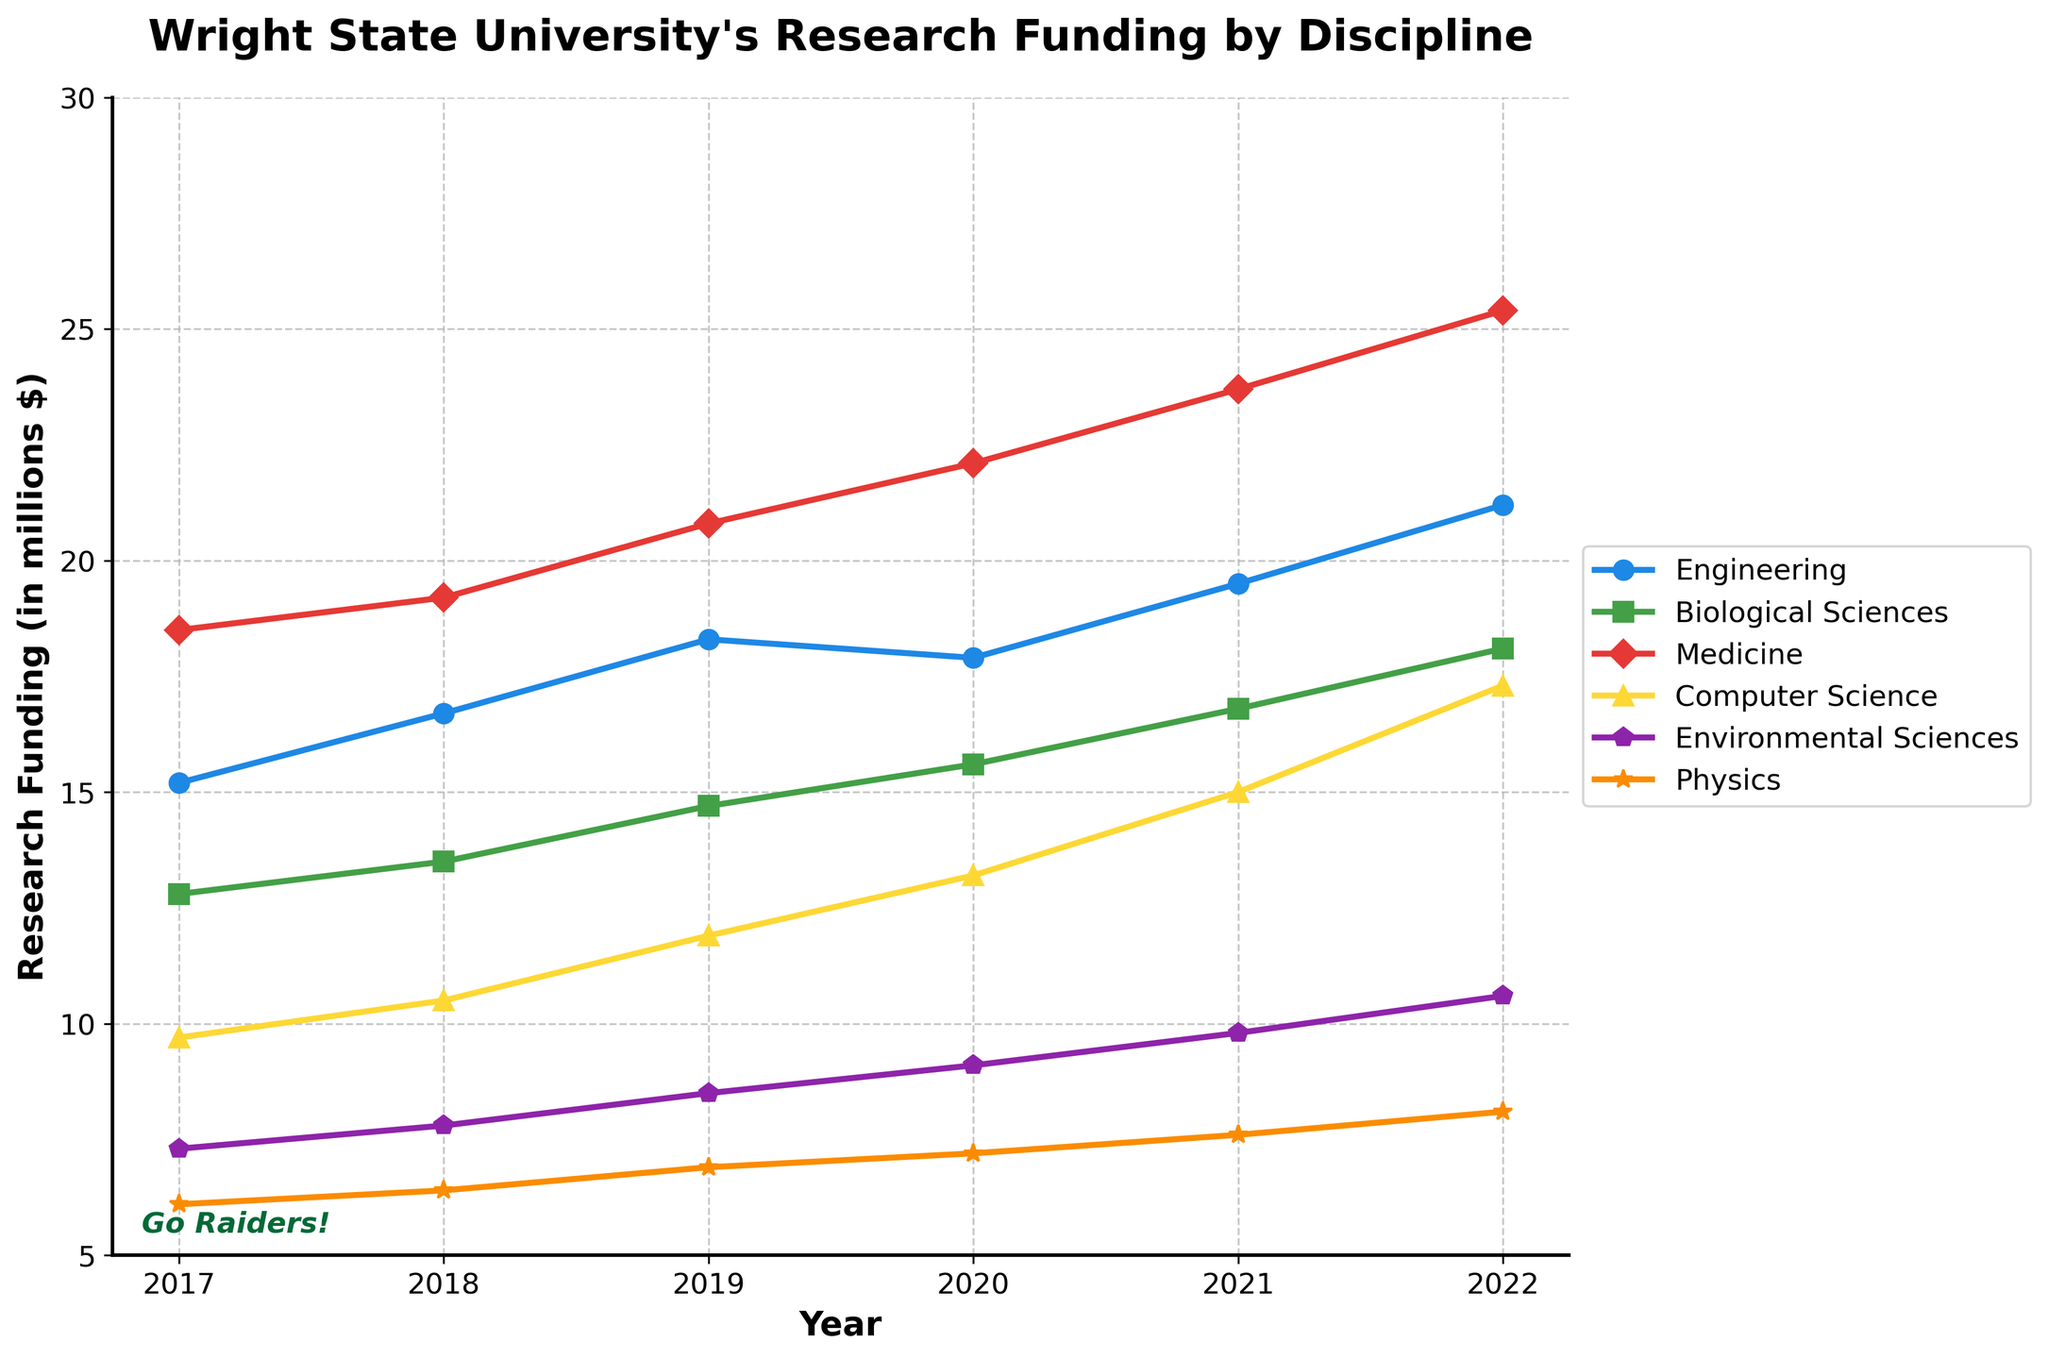What was the trend in research funding for Medicine from 2017 to 2022? First identify the related line for Medicine and then track its trend over the years. The funding amount rises from 18.5 in 2017 to 25.4 in 2022.
Answer: Increasing Which discipline had the highest increase in research funding over the years? Calculate the difference in funding from 2022 and 2017 for each discipline. Engineering increased by 6.0, Biological Sciences by 5.3, Medicine by 6.9, Computer Science by 7.6, Environmental Sciences by 3.3, and Physics by 2.0.
Answer: Computer Science By how much did funding for Environmental Sciences increase from 2017 to 2022? Subtract the 2017 value from the 2022 value for the Environmental Sciences. 10.6 - 7.3 = 3.3
Answer: 3.3 million $ Is there any year where Biological Sciences funding saw a decrease? Identify if the line representing Biological Sciences ever goes down. The funding increases every year.
Answer: No In which year did Physics experience its largest annual funding increase? Calculate the year-over-year changes for Physics: 6.4-6.1=0.3 (2018), 6.9-6.4=0.5 (2019), 7.2-6.9=0.3 (2020), 7.6-7.2=0.4 (2021), 8.1-7.6=0.5 (2022). The largest increase occurred in 2019 and 2022.
Answer: 2019 and 2022 What is the difference in research funding between Engineering and Computer Science in 2020? Identify and subtract the 2020 values for both disciplines: 17.9 (Engineering) - 13.2 (Computer Science) = 4.7
Answer: 4.7 million $ Out of the six disciplines, which one has the most stable funding trend? Compare the trends of all disciplines and identify the one with the least variation. Physics shows the least fluctuation.
Answer: Physics In what year did Computer Science funding surpass 15 million $ for the first time? Identify the year when Computer Science crosses 15 on the y-axis. The value exceeds 15 in 2021.
Answer: 2021 By how much did the total research funding for all disciplines combined increase from 2017 to 2022? Calculate the sum for each year, and find the difference. 2017: 15.2+12.8+18.5+9.7+7.3+6.1 = 69.6; 2022: 21.2+18.1+25.4+17.3+10.6+8.1 = 100.7; Difference: 100.7-69.6 = 31.1
Answer: 31.1 million $ Which year shows the highest overall increase in funding across all disciplines from the previous year? Calculate the combined year-over-year increases: 2018: 2.8, 2019: 5.4, 2020: 4.6, 2021: 6.8, 2022: 8.7. The highest increase is in 2022.
Answer: 2022 